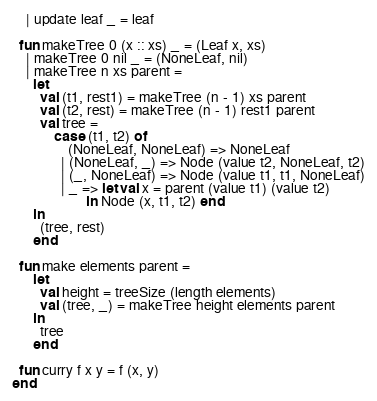<code> <loc_0><loc_0><loc_500><loc_500><_SML_>    | update leaf _ = leaf

  fun makeTree 0 (x :: xs) _ = (Leaf x, xs)
    | makeTree 0 nil _ = (NoneLeaf, nil)
    | makeTree n xs parent =
      let
        val (t1, rest1) = makeTree (n - 1) xs parent
        val (t2, rest) = makeTree (n - 1) rest1 parent
        val tree =
            case (t1, t2) of
                (NoneLeaf, NoneLeaf) => NoneLeaf
              | (NoneLeaf, _) => Node (value t2, NoneLeaf, t2)
              | (_, NoneLeaf) => Node (value t1, t1, NoneLeaf)
              | _ => let val x = parent (value t1) (value t2)
                     in Node (x, t1, t2) end
      in
        (tree, rest)
      end

  fun make elements parent =
      let
        val height = treeSize (length elements)
        val (tree, _) = makeTree height elements parent
      in
        tree
      end

  fun curry f x y = f (x, y)
end
</code> 